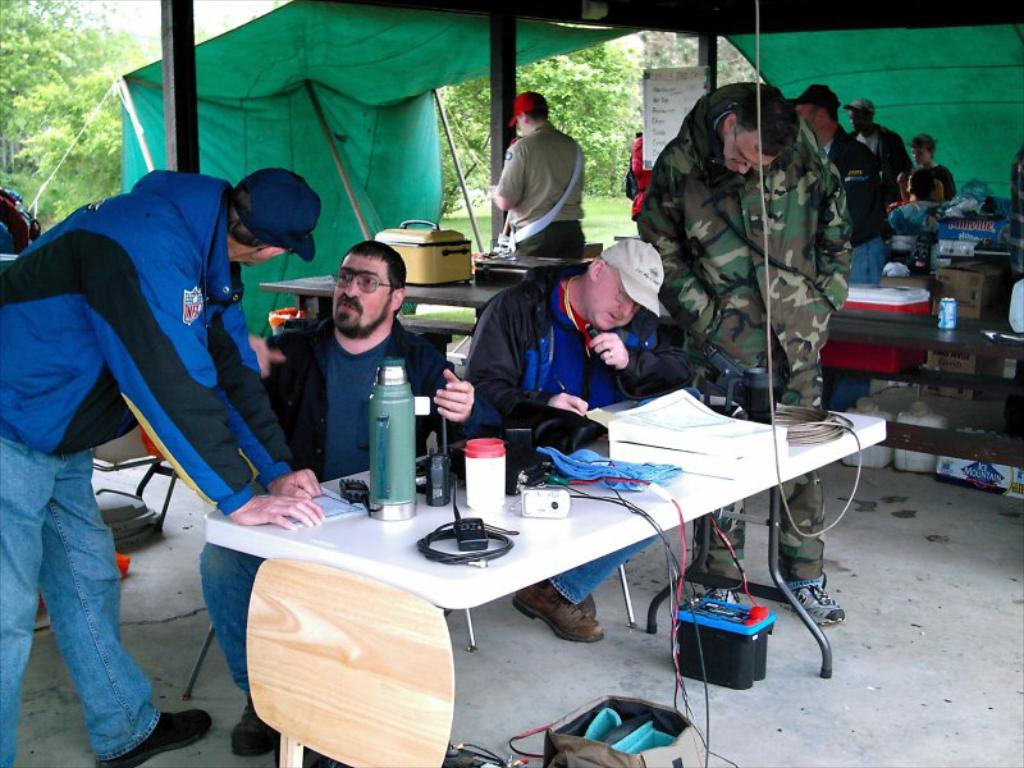How many people are in the image? There are many people in the image. Where are the people located in the image? The people are standing under a tent. What is present in the image besides the people? There is a table in the image. What can be seen on the table in the image? There are water bottles in the image. What type of bubble can be seen floating in the image? There is no bubble present in the image. What color is the flag that is being waved by the cent in the image? There is no cent or flag present in the image. 